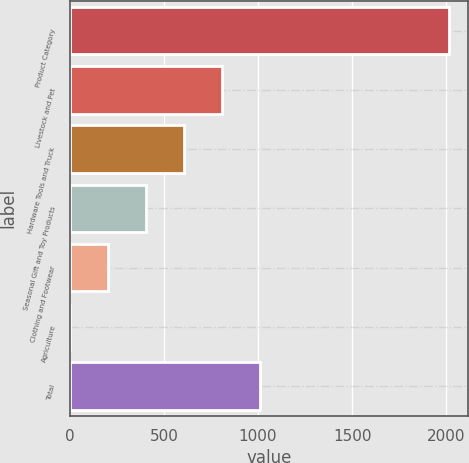Convert chart. <chart><loc_0><loc_0><loc_500><loc_500><bar_chart><fcel>Product Category<fcel>Livestock and Pet<fcel>Hardware Tools and Truck<fcel>Seasonal Gift and Toy Products<fcel>Clothing and Footwear<fcel>Agriculture<fcel>Total<nl><fcel>2017<fcel>809.2<fcel>607.9<fcel>406.6<fcel>205.3<fcel>4<fcel>1010.5<nl></chart> 